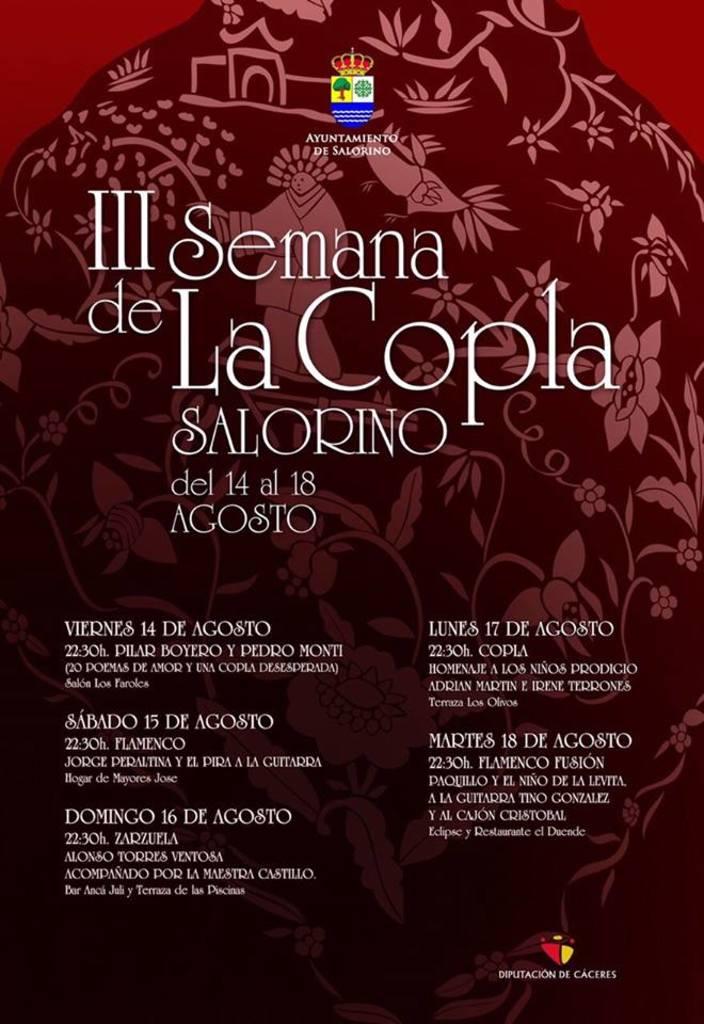Title of this event?
Your answer should be compact. Iii semana de la copla salorino. Is this poster readable to monolingual english speakers?
Keep it short and to the point. No. 